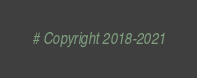Convert code to text. <code><loc_0><loc_0><loc_500><loc_500><_Python_># Copyright 2018-2021</code> 